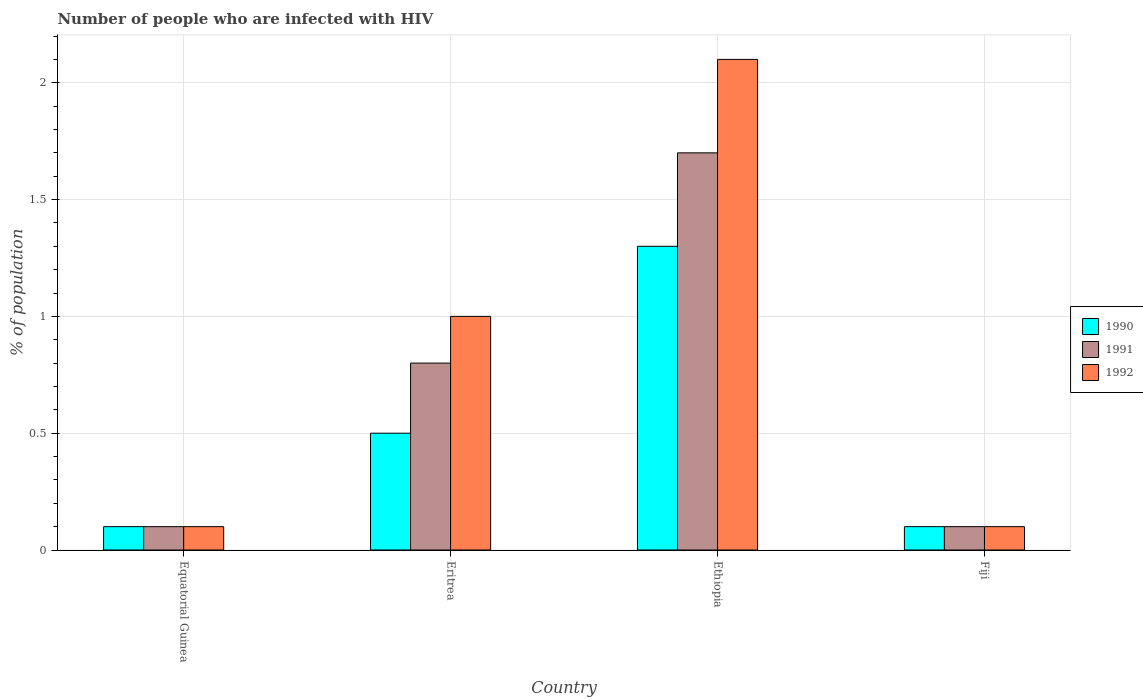How many different coloured bars are there?
Your answer should be very brief. 3. How many groups of bars are there?
Your answer should be compact. 4. Are the number of bars per tick equal to the number of legend labels?
Offer a very short reply. Yes. Are the number of bars on each tick of the X-axis equal?
Offer a very short reply. Yes. How many bars are there on the 3rd tick from the left?
Your answer should be very brief. 3. How many bars are there on the 3rd tick from the right?
Offer a terse response. 3. What is the label of the 1st group of bars from the left?
Offer a terse response. Equatorial Guinea. In how many cases, is the number of bars for a given country not equal to the number of legend labels?
Offer a very short reply. 0. What is the percentage of HIV infected population in in 1991 in Eritrea?
Ensure brevity in your answer.  0.8. Across all countries, what is the maximum percentage of HIV infected population in in 1990?
Your answer should be compact. 1.3. Across all countries, what is the minimum percentage of HIV infected population in in 1992?
Make the answer very short. 0.1. In which country was the percentage of HIV infected population in in 1991 maximum?
Your response must be concise. Ethiopia. In which country was the percentage of HIV infected population in in 1991 minimum?
Provide a short and direct response. Equatorial Guinea. What is the total percentage of HIV infected population in in 1992 in the graph?
Give a very brief answer. 3.3. What is the difference between the percentage of HIV infected population in in 1991 in Eritrea and that in Fiji?
Provide a short and direct response. 0.7. What is the difference between the percentage of HIV infected population in in 1991 in Eritrea and the percentage of HIV infected population in in 1990 in Equatorial Guinea?
Your response must be concise. 0.7. What is the difference between the percentage of HIV infected population in of/in 1992 and percentage of HIV infected population in of/in 1991 in Eritrea?
Your response must be concise. 0.2. What is the ratio of the percentage of HIV infected population in in 1990 in Ethiopia to that in Fiji?
Provide a succinct answer. 13. Is the percentage of HIV infected population in in 1991 in Equatorial Guinea less than that in Ethiopia?
Your answer should be compact. Yes. Is the difference between the percentage of HIV infected population in in 1992 in Eritrea and Ethiopia greater than the difference between the percentage of HIV infected population in in 1991 in Eritrea and Ethiopia?
Offer a very short reply. No. What is the difference between the highest and the lowest percentage of HIV infected population in in 1990?
Your answer should be very brief. 1.2. In how many countries, is the percentage of HIV infected population in in 1991 greater than the average percentage of HIV infected population in in 1991 taken over all countries?
Provide a succinct answer. 2. What does the 3rd bar from the left in Equatorial Guinea represents?
Provide a succinct answer. 1992. What does the 2nd bar from the right in Ethiopia represents?
Provide a short and direct response. 1991. Is it the case that in every country, the sum of the percentage of HIV infected population in in 1992 and percentage of HIV infected population in in 1990 is greater than the percentage of HIV infected population in in 1991?
Your response must be concise. Yes. How many bars are there?
Give a very brief answer. 12. Are all the bars in the graph horizontal?
Your response must be concise. No. How many countries are there in the graph?
Give a very brief answer. 4. What is the difference between two consecutive major ticks on the Y-axis?
Offer a terse response. 0.5. Are the values on the major ticks of Y-axis written in scientific E-notation?
Your answer should be very brief. No. How are the legend labels stacked?
Keep it short and to the point. Vertical. What is the title of the graph?
Your answer should be very brief. Number of people who are infected with HIV. What is the label or title of the Y-axis?
Your answer should be compact. % of population. What is the % of population in 1991 in Equatorial Guinea?
Give a very brief answer. 0.1. What is the % of population in 1992 in Equatorial Guinea?
Make the answer very short. 0.1. What is the % of population in 1991 in Eritrea?
Provide a short and direct response. 0.8. What is the % of population in 1991 in Ethiopia?
Your answer should be very brief. 1.7. What is the % of population in 1992 in Fiji?
Offer a very short reply. 0.1. Across all countries, what is the maximum % of population in 1990?
Provide a succinct answer. 1.3. Across all countries, what is the maximum % of population in 1992?
Give a very brief answer. 2.1. Across all countries, what is the minimum % of population in 1990?
Provide a short and direct response. 0.1. Across all countries, what is the minimum % of population in 1992?
Keep it short and to the point. 0.1. What is the total % of population of 1990 in the graph?
Offer a terse response. 2. What is the total % of population in 1991 in the graph?
Your response must be concise. 2.7. What is the difference between the % of population of 1992 in Equatorial Guinea and that in Eritrea?
Offer a very short reply. -0.9. What is the difference between the % of population in 1990 in Equatorial Guinea and that in Fiji?
Provide a short and direct response. 0. What is the difference between the % of population of 1991 in Equatorial Guinea and that in Fiji?
Your response must be concise. 0. What is the difference between the % of population of 1990 in Eritrea and that in Ethiopia?
Your answer should be compact. -0.8. What is the difference between the % of population of 1990 in Eritrea and that in Fiji?
Give a very brief answer. 0.4. What is the difference between the % of population in 1991 in Eritrea and that in Fiji?
Ensure brevity in your answer.  0.7. What is the difference between the % of population in 1992 in Eritrea and that in Fiji?
Provide a succinct answer. 0.9. What is the difference between the % of population in 1991 in Ethiopia and that in Fiji?
Offer a very short reply. 1.6. What is the difference between the % of population in 1992 in Ethiopia and that in Fiji?
Offer a very short reply. 2. What is the difference between the % of population in 1990 in Equatorial Guinea and the % of population in 1991 in Eritrea?
Offer a very short reply. -0.7. What is the difference between the % of population of 1990 in Equatorial Guinea and the % of population of 1992 in Ethiopia?
Ensure brevity in your answer.  -2. What is the difference between the % of population in 1990 in Equatorial Guinea and the % of population in 1992 in Fiji?
Your answer should be compact. 0. What is the difference between the % of population of 1991 in Equatorial Guinea and the % of population of 1992 in Fiji?
Offer a very short reply. 0. What is the difference between the % of population of 1990 in Eritrea and the % of population of 1992 in Ethiopia?
Your answer should be compact. -1.6. What is the difference between the % of population of 1991 in Eritrea and the % of population of 1992 in Ethiopia?
Offer a terse response. -1.3. What is the difference between the % of population of 1990 in Eritrea and the % of population of 1991 in Fiji?
Provide a short and direct response. 0.4. What is the difference between the % of population in 1991 in Eritrea and the % of population in 1992 in Fiji?
Offer a terse response. 0.7. What is the difference between the % of population in 1990 in Ethiopia and the % of population in 1992 in Fiji?
Your response must be concise. 1.2. What is the average % of population in 1991 per country?
Give a very brief answer. 0.68. What is the average % of population in 1992 per country?
Give a very brief answer. 0.82. What is the difference between the % of population in 1990 and % of population in 1991 in Equatorial Guinea?
Offer a terse response. 0. What is the difference between the % of population in 1990 and % of population in 1992 in Equatorial Guinea?
Give a very brief answer. 0. What is the difference between the % of population in 1990 and % of population in 1992 in Eritrea?
Offer a very short reply. -0.5. What is the difference between the % of population in 1990 and % of population in 1991 in Ethiopia?
Offer a very short reply. -0.4. What is the difference between the % of population of 1991 and % of population of 1992 in Ethiopia?
Ensure brevity in your answer.  -0.4. What is the difference between the % of population in 1990 and % of population in 1991 in Fiji?
Make the answer very short. 0. What is the difference between the % of population in 1991 and % of population in 1992 in Fiji?
Your answer should be very brief. 0. What is the ratio of the % of population of 1991 in Equatorial Guinea to that in Eritrea?
Make the answer very short. 0.12. What is the ratio of the % of population in 1990 in Equatorial Guinea to that in Ethiopia?
Your response must be concise. 0.08. What is the ratio of the % of population of 1991 in Equatorial Guinea to that in Ethiopia?
Your answer should be very brief. 0.06. What is the ratio of the % of population of 1992 in Equatorial Guinea to that in Ethiopia?
Make the answer very short. 0.05. What is the ratio of the % of population of 1990 in Eritrea to that in Ethiopia?
Your answer should be very brief. 0.38. What is the ratio of the % of population of 1991 in Eritrea to that in Ethiopia?
Make the answer very short. 0.47. What is the ratio of the % of population of 1992 in Eritrea to that in Ethiopia?
Give a very brief answer. 0.48. What is the ratio of the % of population in 1990 in Eritrea to that in Fiji?
Your response must be concise. 5. What is the ratio of the % of population in 1992 in Eritrea to that in Fiji?
Offer a very short reply. 10. What is the ratio of the % of population in 1991 in Ethiopia to that in Fiji?
Your answer should be compact. 17. What is the ratio of the % of population in 1992 in Ethiopia to that in Fiji?
Your response must be concise. 21. What is the difference between the highest and the second highest % of population of 1990?
Give a very brief answer. 0.8. 